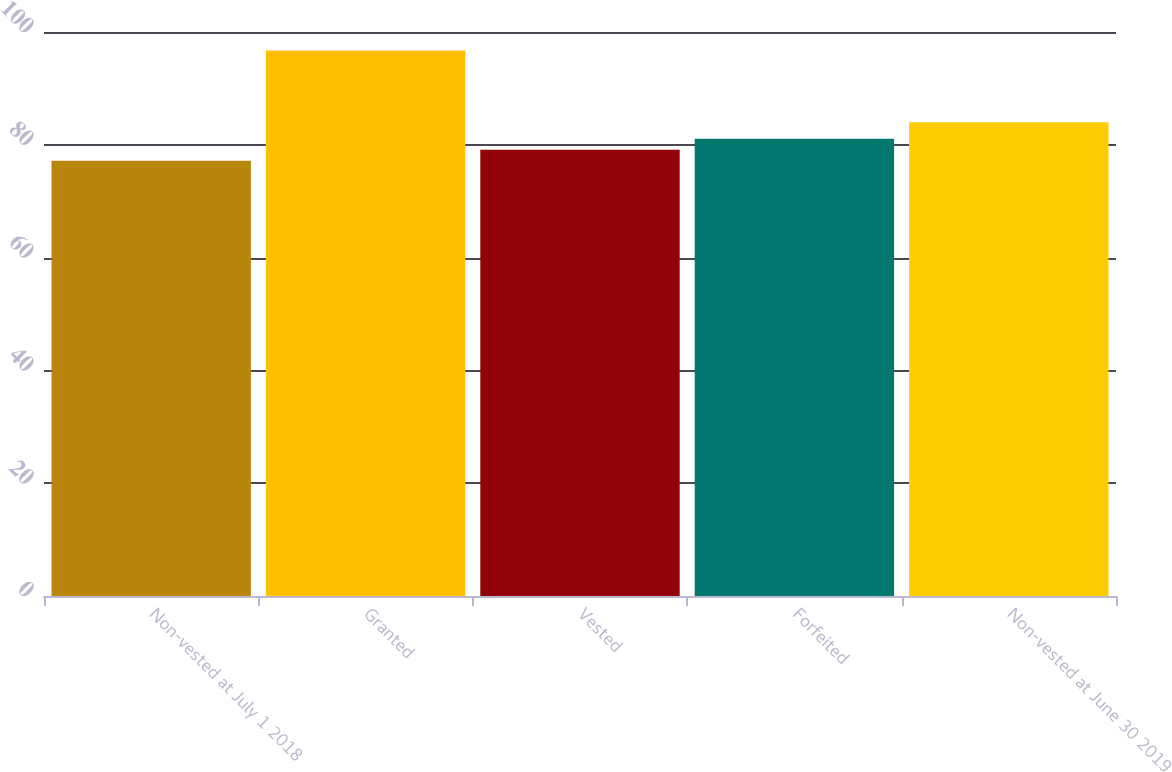Convert chart. <chart><loc_0><loc_0><loc_500><loc_500><bar_chart><fcel>Non-vested at July 1 2018<fcel>Granted<fcel>Vested<fcel>Forfeited<fcel>Non-vested at June 30 2019<nl><fcel>77.17<fcel>96.74<fcel>79.13<fcel>81.09<fcel>84<nl></chart> 